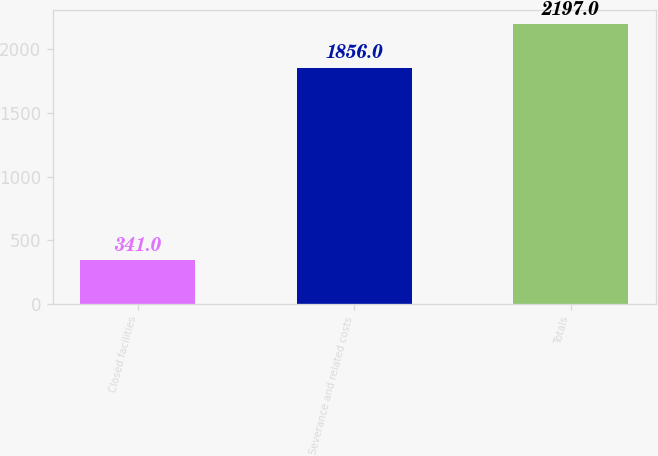Convert chart to OTSL. <chart><loc_0><loc_0><loc_500><loc_500><bar_chart><fcel>Closed facilities<fcel>Severance and related costs<fcel>Totals<nl><fcel>341<fcel>1856<fcel>2197<nl></chart> 